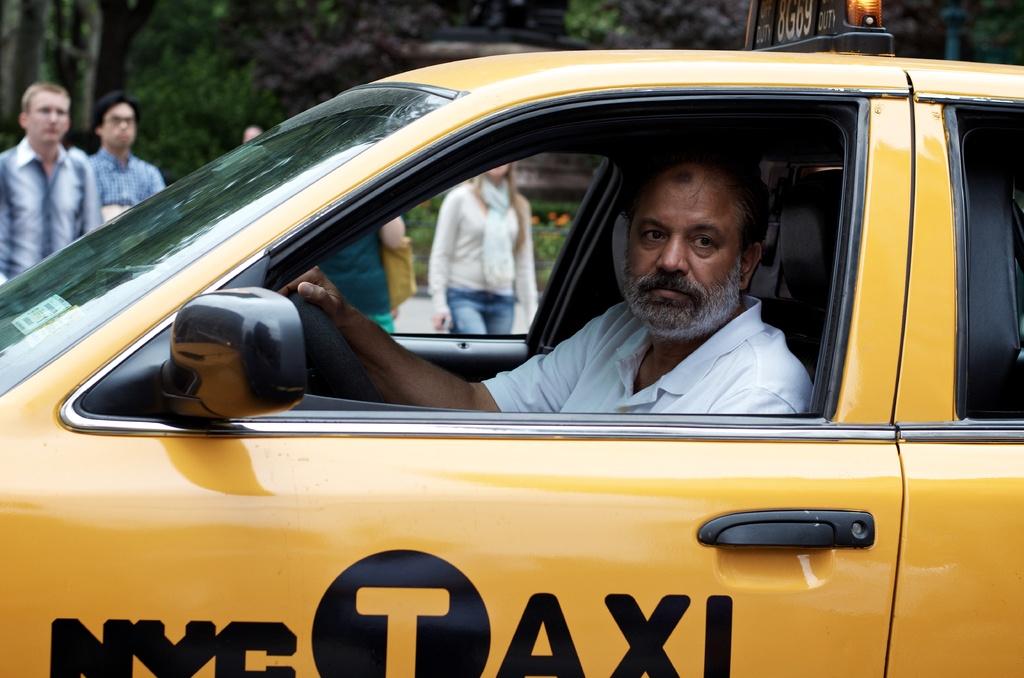Where is the taxi from?
Your answer should be compact. Nyc. 